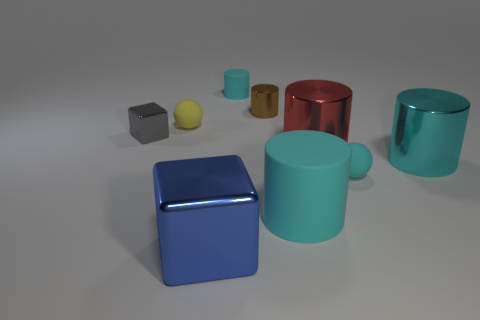There is a big cylinder that is the same color as the large matte thing; what is its material?
Give a very brief answer. Metal. There is a large red object in front of the tiny cyan object behind the cyan matte sphere; what is its material?
Make the answer very short. Metal. How many small things are yellow matte objects or metal things?
Provide a short and direct response. 3. What is the size of the yellow sphere?
Make the answer very short. Small. Is the number of tiny yellow rubber balls to the left of the tiny cyan rubber cylinder greater than the number of tiny green rubber cubes?
Offer a terse response. Yes. Is the number of small yellow objects that are in front of the yellow rubber thing the same as the number of large cyan metal things that are behind the blue metallic thing?
Your answer should be very brief. No. What color is the tiny thing that is in front of the tiny yellow matte sphere and right of the small block?
Provide a short and direct response. Cyan. Is the number of tiny brown objects right of the large blue shiny thing greater than the number of small shiny objects behind the yellow rubber thing?
Your answer should be compact. No. Do the sphere left of the brown cylinder and the red metal cylinder have the same size?
Give a very brief answer. No. There is a rubber ball that is right of the small rubber sphere to the left of the big blue object; what number of metal things are in front of it?
Make the answer very short. 1. 